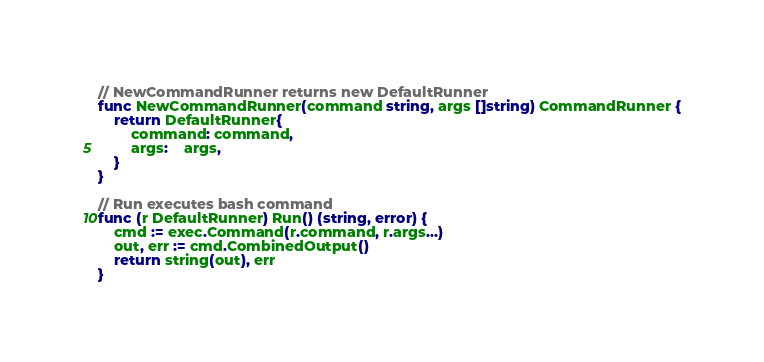Convert code to text. <code><loc_0><loc_0><loc_500><loc_500><_Go_>
// NewCommandRunner returns new DefaultRunner
func NewCommandRunner(command string, args []string) CommandRunner {
	return DefaultRunner{
		command: command,
		args:    args,
	}
}

// Run executes bash command
func (r DefaultRunner) Run() (string, error) {
	cmd := exec.Command(r.command, r.args...)
	out, err := cmd.CombinedOutput()
	return string(out), err
}
</code> 